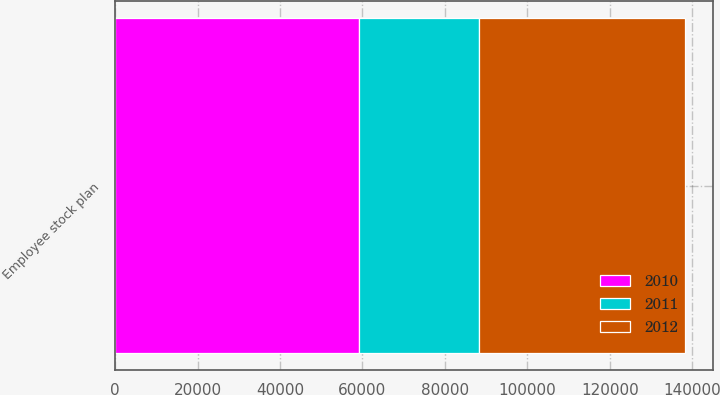<chart> <loc_0><loc_0><loc_500><loc_500><stacked_bar_chart><ecel><fcel>Employee stock plan<nl><fcel>2012<fcel>50045<nl><fcel>2011<fcel>29017<nl><fcel>2010<fcel>59164<nl></chart> 